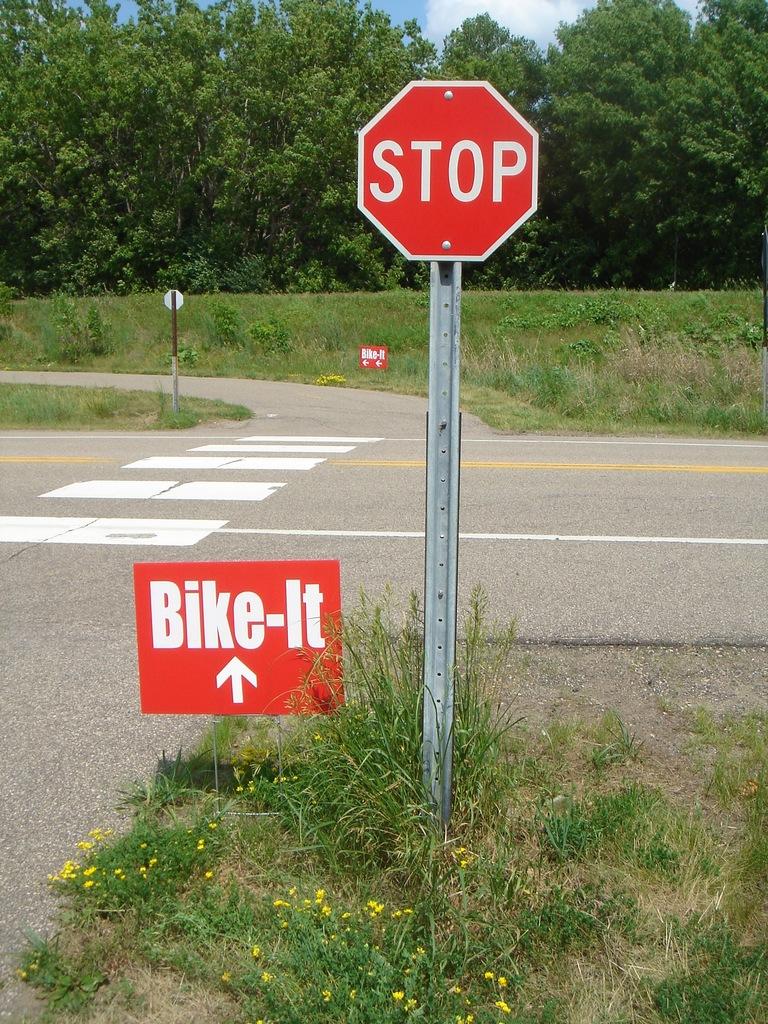What kind of trail is ahead?
Ensure brevity in your answer.  Bike. What type of traffic sign is this?
Offer a very short reply. Stop. 